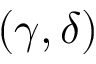Convert formula to latex. <formula><loc_0><loc_0><loc_500><loc_500>( \gamma , \delta )</formula> 